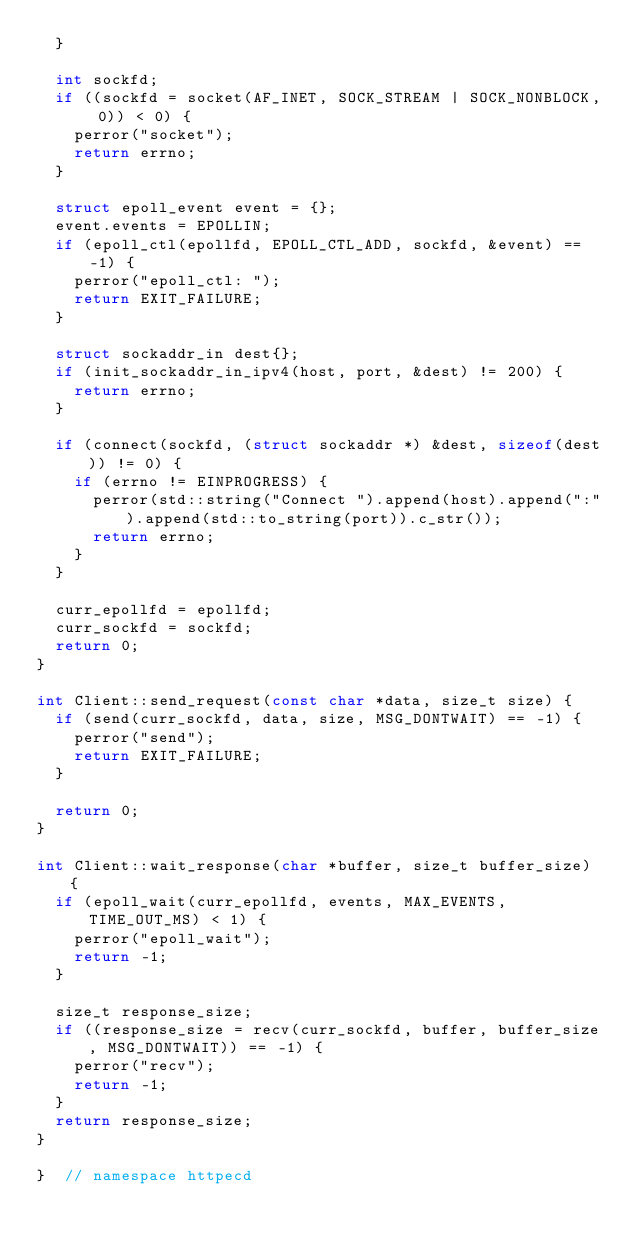<code> <loc_0><loc_0><loc_500><loc_500><_C++_>  }

  int sockfd;
  if ((sockfd = socket(AF_INET, SOCK_STREAM | SOCK_NONBLOCK, 0)) < 0) {
    perror("socket");
    return errno;
  }

  struct epoll_event event = {};
  event.events = EPOLLIN;
  if (epoll_ctl(epollfd, EPOLL_CTL_ADD, sockfd, &event) == -1) {
    perror("epoll_ctl: ");
    return EXIT_FAILURE;
  }

  struct sockaddr_in dest{};
  if (init_sockaddr_in_ipv4(host, port, &dest) != 200) {
    return errno;
  }

  if (connect(sockfd, (struct sockaddr *) &dest, sizeof(dest)) != 0) {
    if (errno != EINPROGRESS) {
      perror(std::string("Connect ").append(host).append(":").append(std::to_string(port)).c_str());
      return errno;
    }
  }

  curr_epollfd = epollfd;
  curr_sockfd = sockfd;
  return 0;
}

int Client::send_request(const char *data, size_t size) {
  if (send(curr_sockfd, data, size, MSG_DONTWAIT) == -1) {
    perror("send");
    return EXIT_FAILURE;
  }

  return 0;
}

int Client::wait_response(char *buffer, size_t buffer_size) {
  if (epoll_wait(curr_epollfd, events, MAX_EVENTS, TIME_OUT_MS) < 1) {
    perror("epoll_wait");
    return -1;
  }

  size_t response_size;
  if ((response_size = recv(curr_sockfd, buffer, buffer_size, MSG_DONTWAIT)) == -1) {
    perror("recv");
    return -1;
  }
  return response_size;
}

}  // namespace httpecd
</code> 